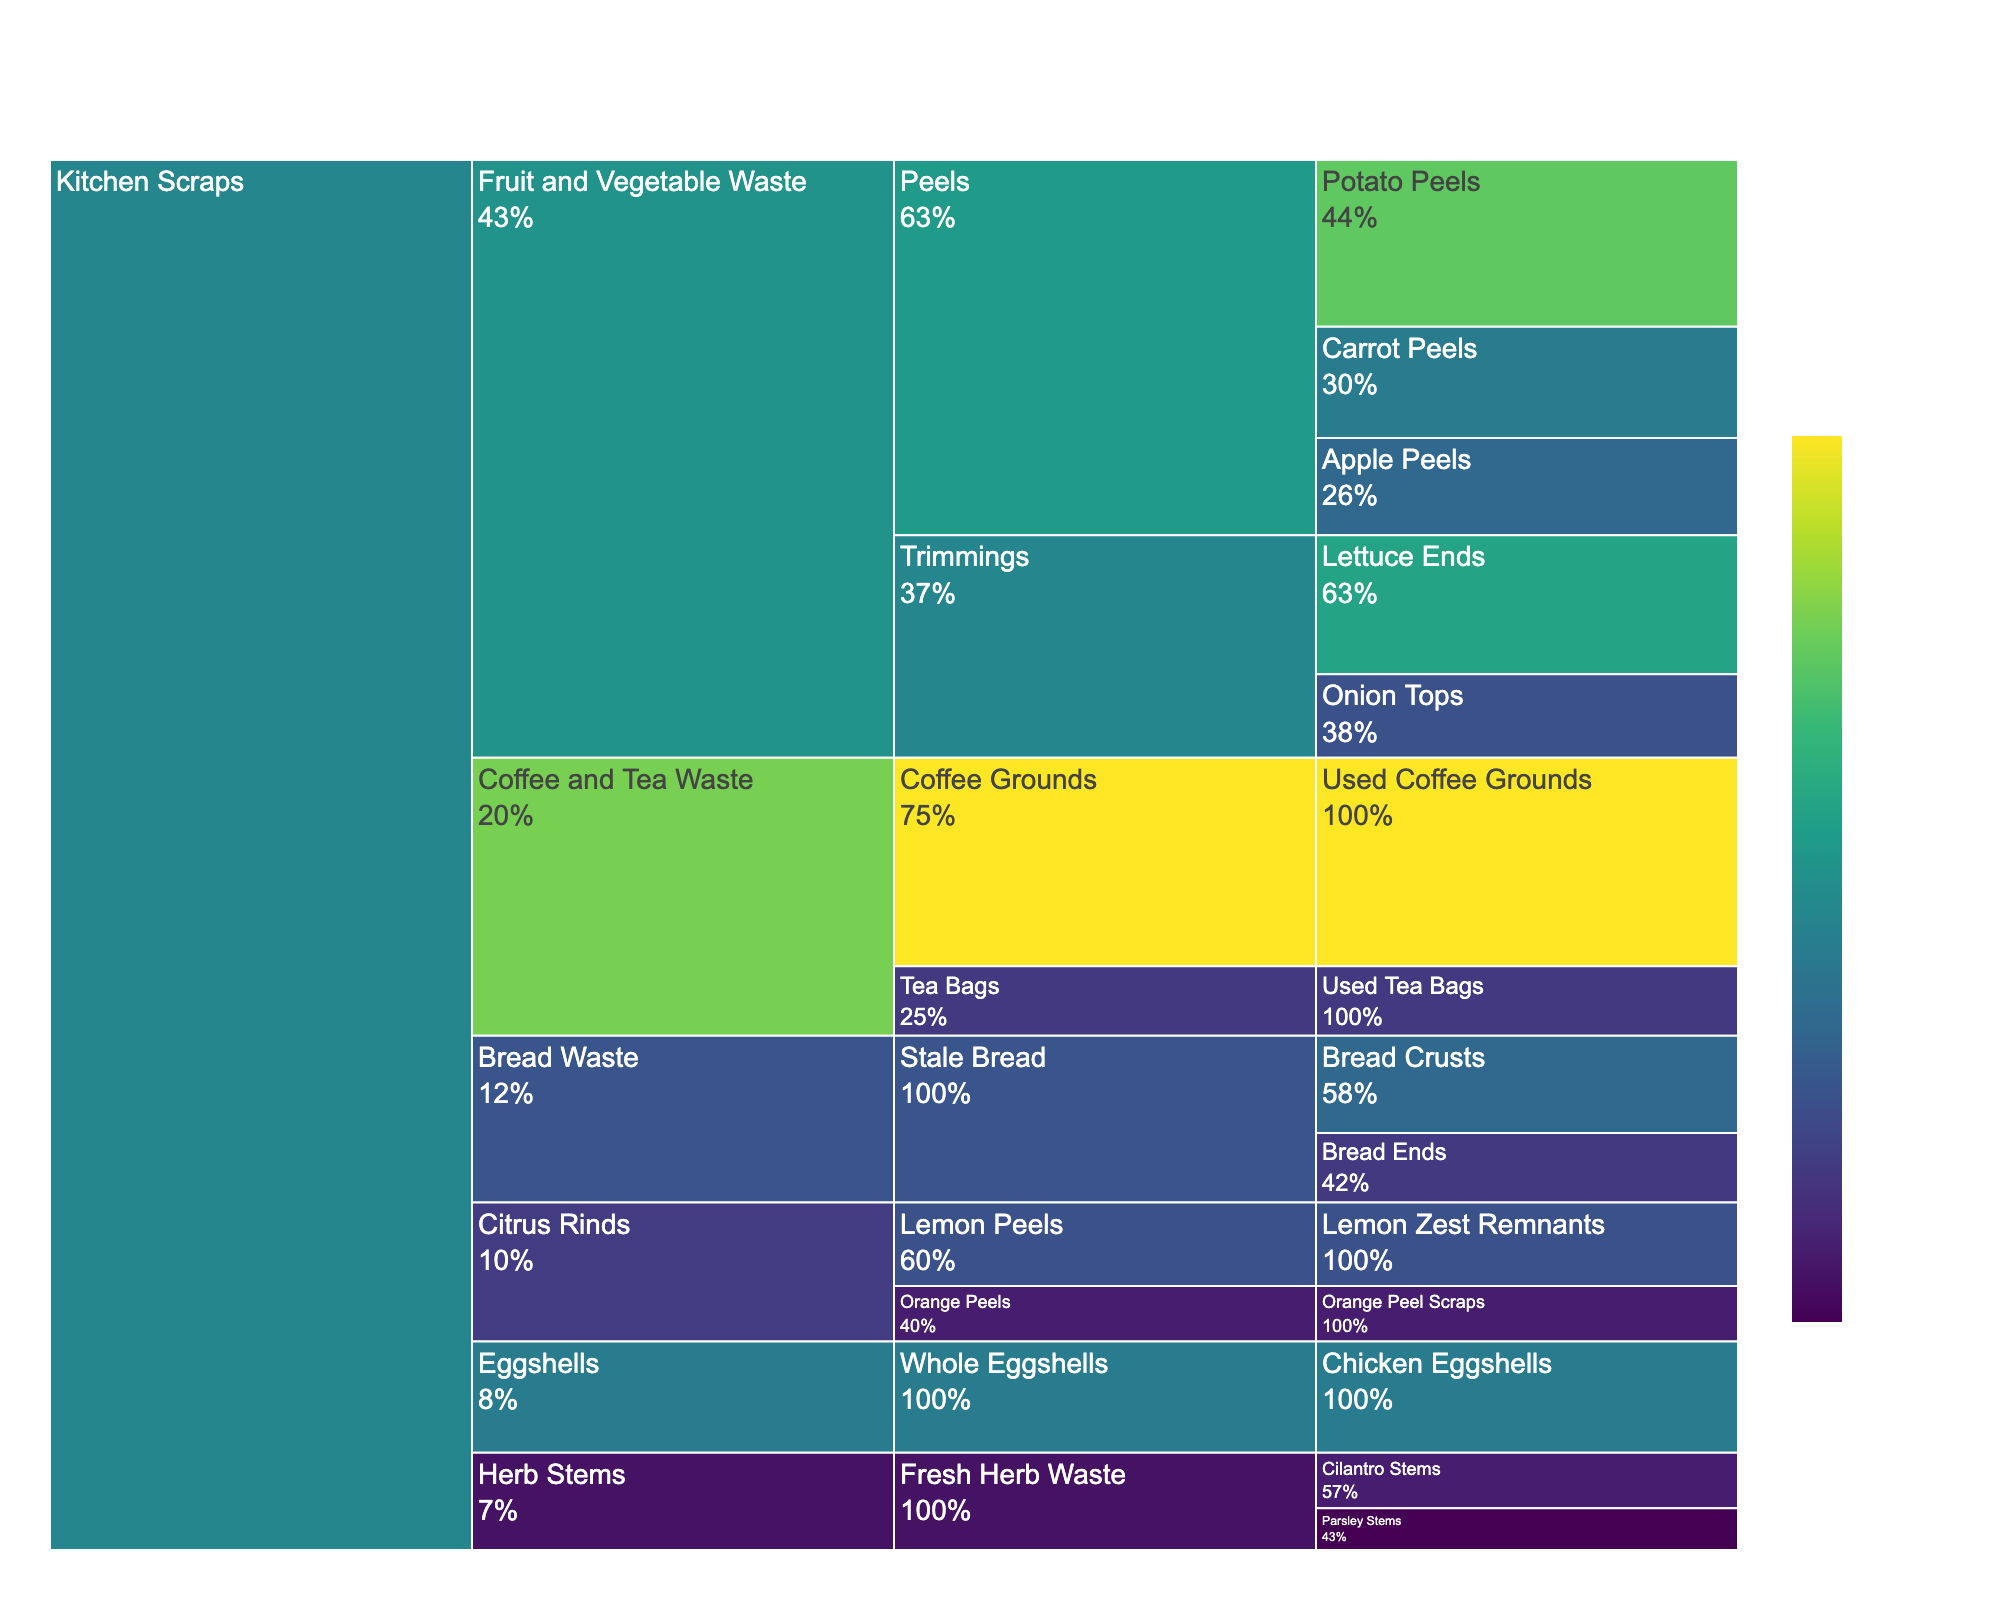what is the title of the figure? The title of the figure is generally displayed at the top of the chart, summarizing the content.
Answer: Composition of Kitchen Scraps Compost Materials Which item has the highest percentage in the chart? To find the item with the highest percentage, locate the item with the largest value in the chart. The largest segment represents the item with the highest percentage.
Answer: Used Coffee Grounds What is the combined percentage of Potato Peels and Carrot Peels? To find the combined percentage, add the percentages of both items together: 12% (Potato Peels) + 8% (Carrot Peels) = 20%.
Answer: 20% How does the percentage of Lettuce Ends compare to Onion Tops? Compare their percentages directly: Lettuce Ends have a percentage of 10% while Onion Tops have 6%, showing that Lettuce Ends have a higher value.
Answer: Lettuce Ends (10%) > Onion Tops (6%) Which category contributes more to the compost, Fruit and Vegetable Waste or Coffee and Tea Waste? Sum the percentages of items under each category: Fruit and Vegetable Waste (12+8+7+10+6 = 43%) and Coffee and Tea Waste (15+5 = 20%). Thus, Fruit and Vegetable Waste contributes more.
Answer: Fruit and Vegetable Waste What fraction of the total does Stale Bread contribute? Combine Bread Crusts and Bread Ends (7% + 5% = 12%). Stale Bread contributes 12% of the total.
Answer: 12% What are the categories mentioned in the chart? Identify the distinct major categories from the chart: Fruit and Vegetable Waste, Coffee and Tea Waste, Eggshells, Bread Waste, Herb Stems, and Citrus Rinds.
Answer: Six categories Which has a smaller percentage, Orange Peel Scraps or Parsley Stems? Compare their percentages: Orange Peel Scraps have 4% and Parsley Stems have 3%. Hence, Parsley Stems are smaller.
Answer: Parsley Stems (3%) How much more percentage does Used Coffee Grounds have compared to Apple Peels? Subtract Apple Peels' percentage from Used Coffee Grounds' percentage: 15% - 7% = 8%.
Answer: 8% Which subcategory under Fruit and Vegetable Waste has the highest percentage? Look for the subcategory with the highest sum of its items' percentages under Fruit and Vegetable Waste. Sum for 'Peels' (Peels: 12+8+7=27%) and 'Trimmings' (Trimmings: 10+6=16%). Thus, 'Peels' is the highest.
Answer: Peels 